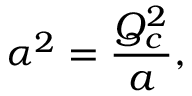Convert formula to latex. <formula><loc_0><loc_0><loc_500><loc_500>\alpha ^ { 2 } = { \frac { Q _ { c } ^ { 2 } } { a } } ,</formula> 